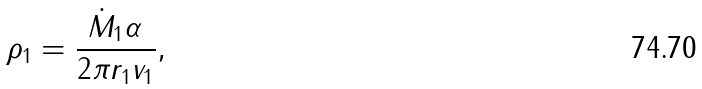Convert formula to latex. <formula><loc_0><loc_0><loc_500><loc_500>\rho _ { 1 } = \frac { \dot { M } _ { 1 } \alpha } { 2 \pi r _ { 1 } v _ { 1 } } ,</formula> 